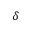<formula> <loc_0><loc_0><loc_500><loc_500>\delta</formula> 